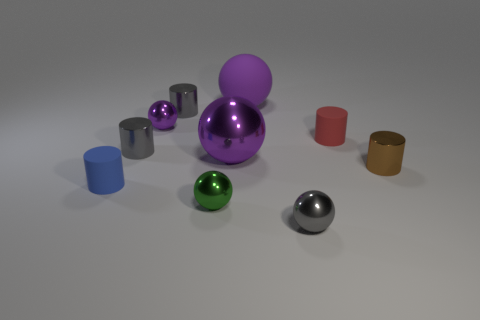What materials do these objects seem to be made from? The objects in the image appear to be made of different materials with metallic and matte finishes. The spheres and cylinders have a reflective quality suggesting they are metallic, while the cube appears to have a matte surface, indicating a non-metallic, possibly plastic material. 